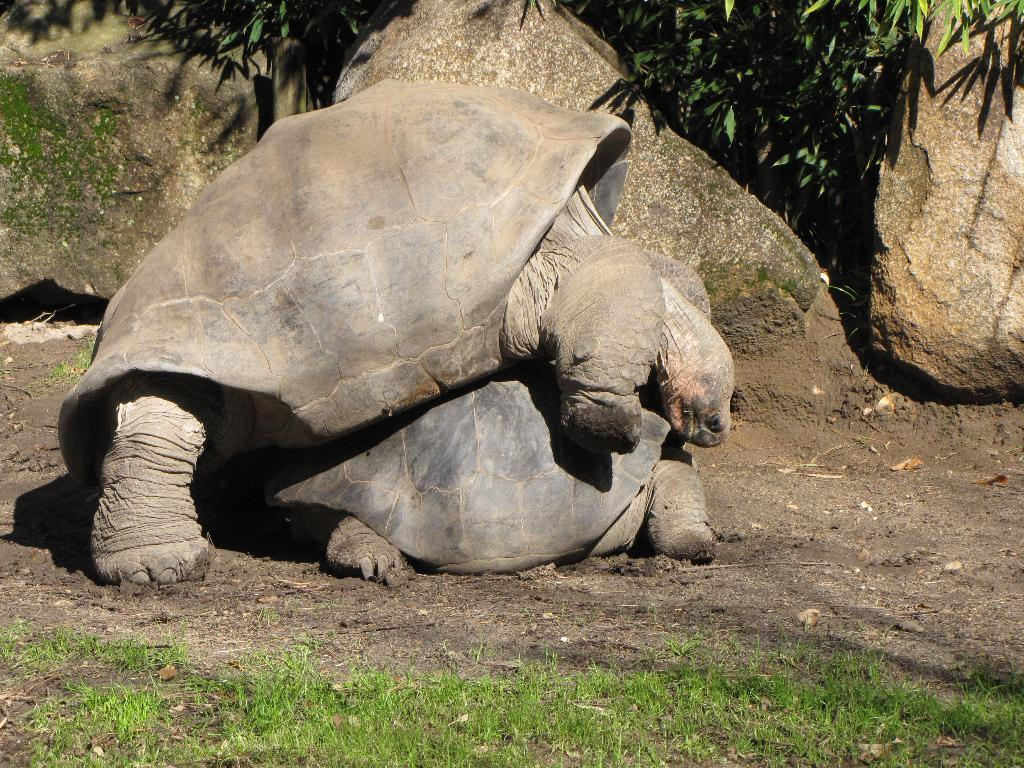What type of animals are present in the image? There are tortoises in the image. What type of vegetation can be seen in the image? There is grass in the image. What can be seen in the background of the image? There are rocks and leaves in the background of the image. What rhythm do the snails follow while moving in the image? There are no snails present in the image, so there is no rhythm to follow. 